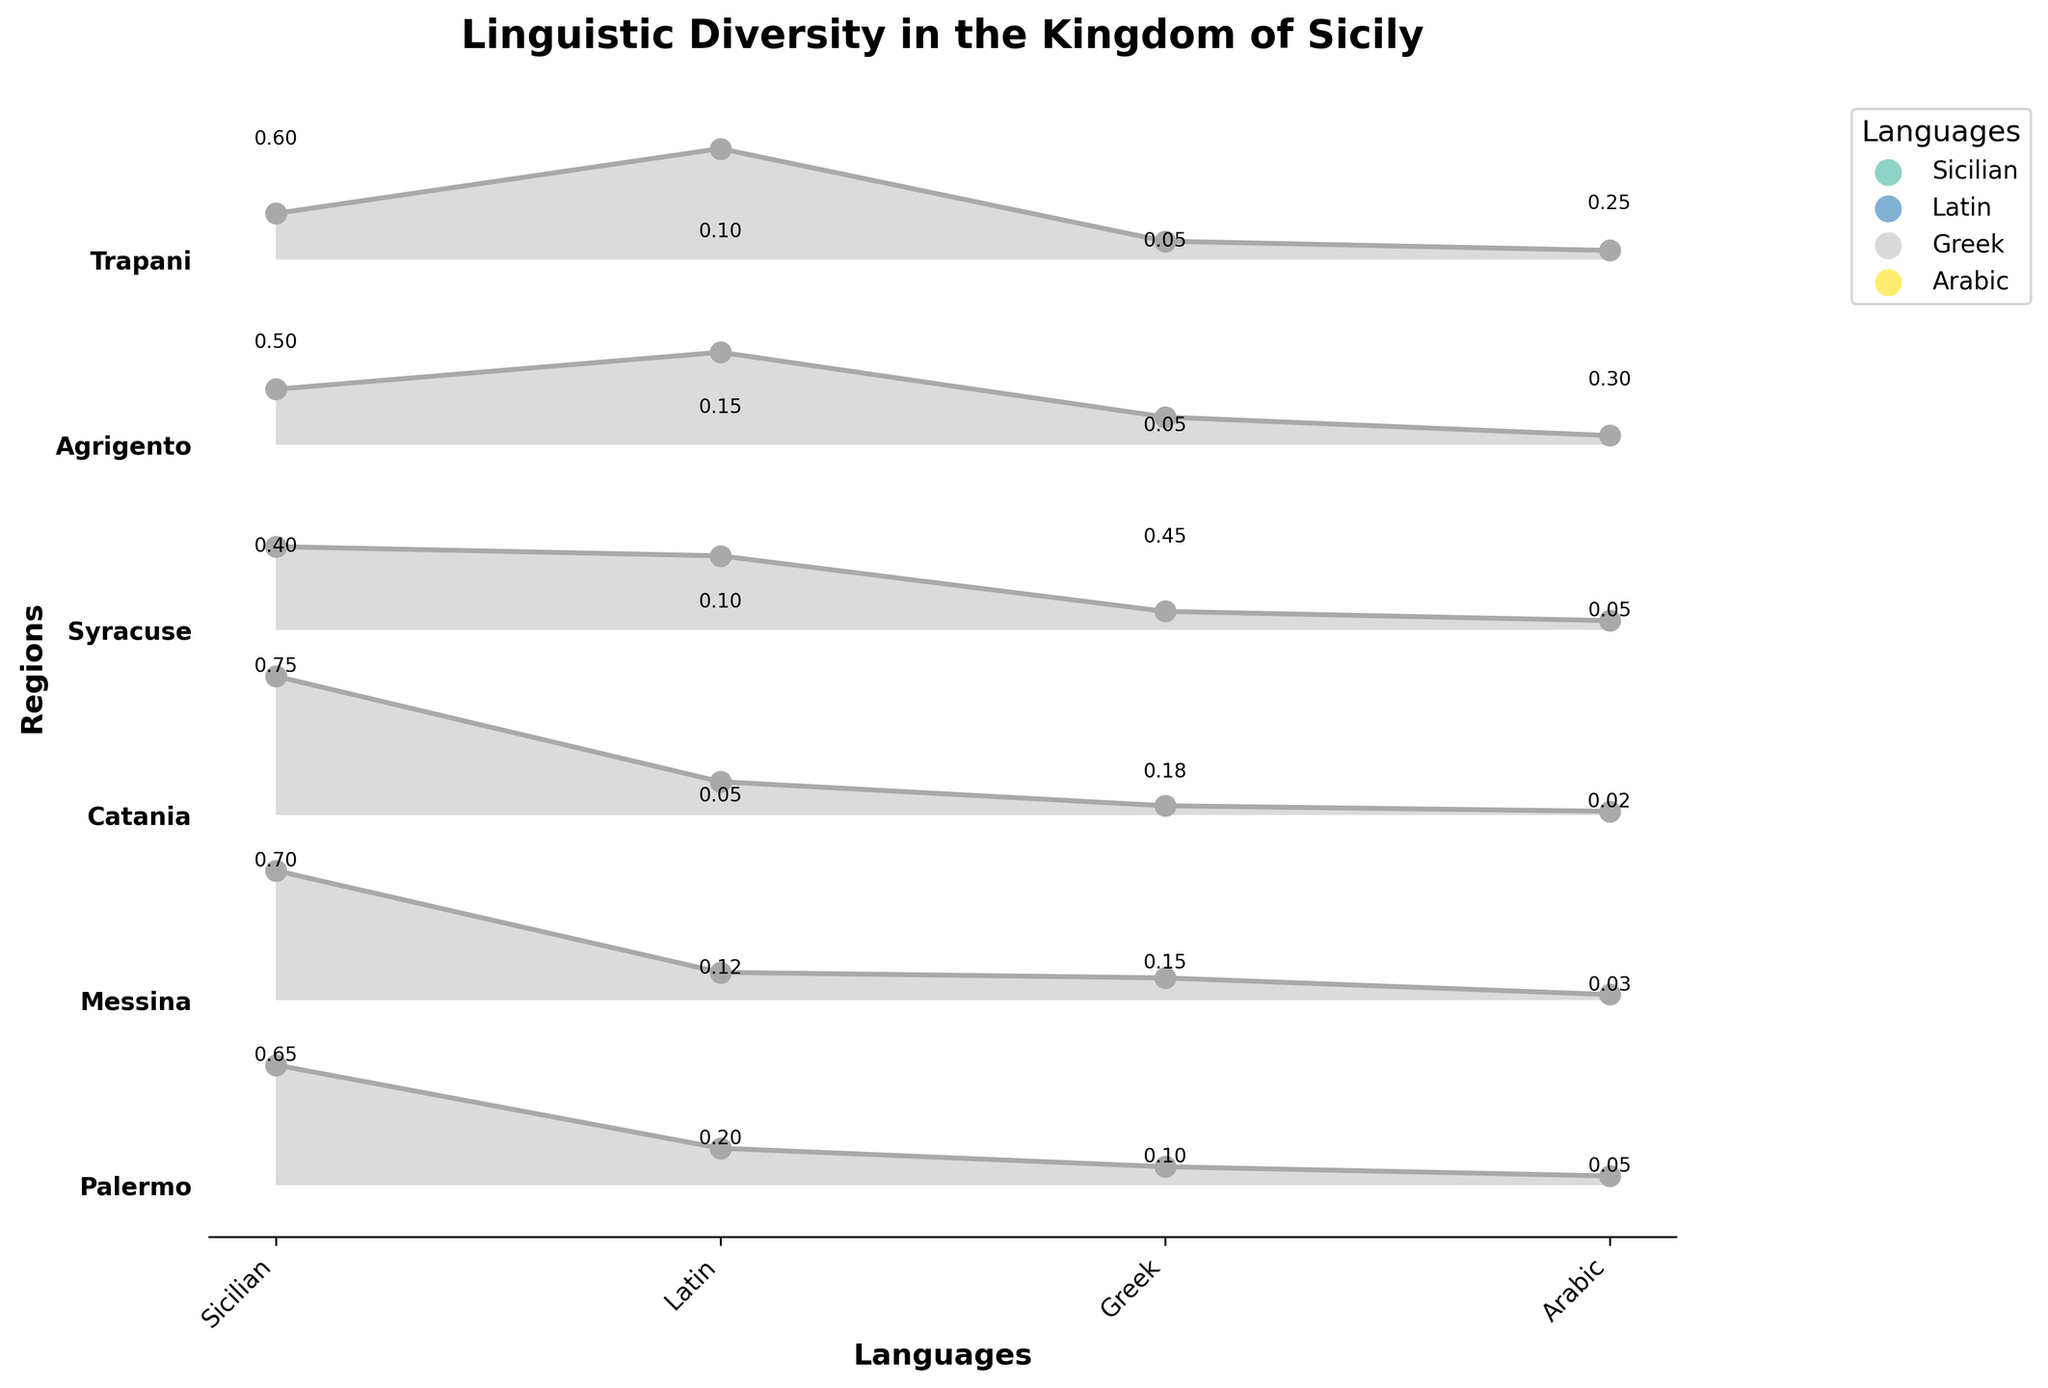What's the most prevalent language in Palermo? By observing the heights of the sections in the plot for Palermo, we can see which language has the highest prevalence value. Here, Sicilian has the highest prevalence value of 0.65.
Answer: Sicilian Which region has the highest prevalence of Arabic? By comparing the heights of the sections representing Arabic across different regions, Agrigento stands out with the highest prevalence value of 0.30.
Answer: Agrigento What's the combined prevalence of Latin and Greek in Syracuse? To find the combined prevalence, we add the prevalence values of Latin and Greek in Syracuse: 0.10 (Latin) + 0.45 (Greek) = 0.55.
Answer: 0.55 Between Catania and Messina, which region has a greater prevalence of Sicilian and by how much? Comparing the heights of the Sicilian sections, Catania has a prevalence of 0.75 while Messina has 0.70. The difference is 0.75 - 0.70 = 0.05.
Answer: Catania by 0.05 Which region shows significant linguistic diversity, having all four languages represented? We need to check which regions have non-zero prevalences for all four languages. Palermo, Messina, Catania, Syracuse, and Agrigento all fit this criterion.
Answer: Palermo, Messina, Catania, Syracuse, Agrigento What is the least prevalent language in Trapani? By identifying the smallest section in the plot for Trapani, we see that Greek has the lowest prevalence value of 0.05.
Answer: Greek What is the average prevalence of Sicilian across all regions? To find the average prevalence, sum the prevalences of Sicilian in all regions and divide by the number of regions: (0.65 + 0.70 + 0.75 + 0.40 + 0.50 + 0.60)/6 = 3.60/6 = 0.60.
Answer: 0.60 In which region is Greek more prevalent than Latin? By comparing the heights of the Greek and Latin sections within each region, we find that Greek is more prevalent than Latin in Catania and Syracuse.
Answer: Catania, Syracuse What's the prevalence difference between the most and least prevalent languages in Agrigento? Sicilian is the most prevalent (0.50) and Greek is the least prevalent (0.05). The difference is 0.50 - 0.05 = 0.45.
Answer: 0.45 Which region has the smallest prevalence of Sicilian? By identifying the smallest Sicilian section among all regions, Syracuse has the lowest prevalence of 0.40.
Answer: Syracuse 